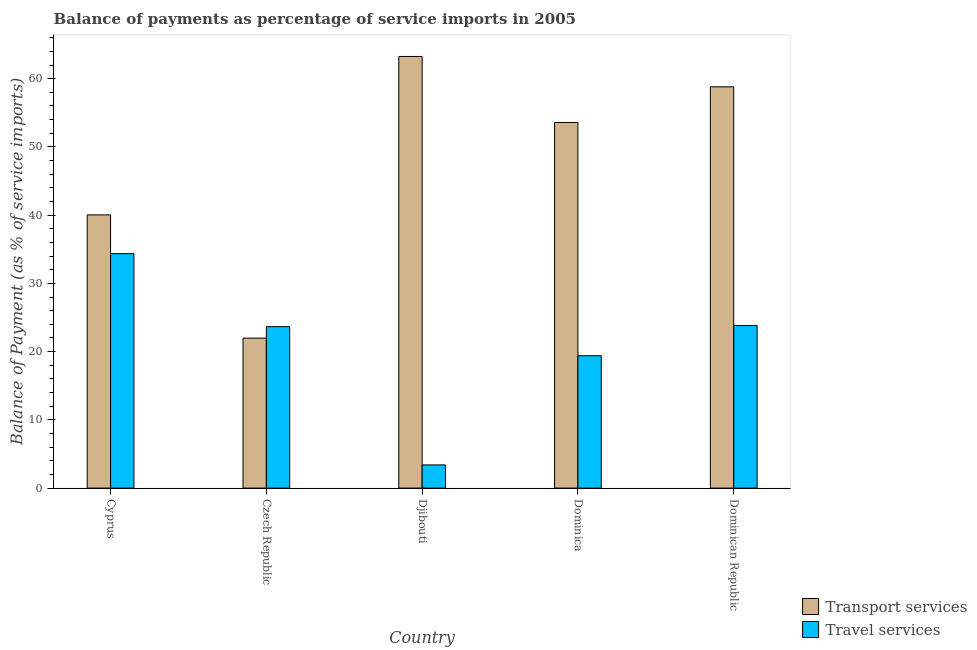How many different coloured bars are there?
Offer a terse response. 2. What is the label of the 3rd group of bars from the left?
Offer a very short reply. Djibouti. What is the balance of payments of transport services in Dominican Republic?
Provide a short and direct response. 58.81. Across all countries, what is the maximum balance of payments of transport services?
Your answer should be very brief. 63.26. Across all countries, what is the minimum balance of payments of transport services?
Provide a succinct answer. 21.98. In which country was the balance of payments of transport services maximum?
Provide a short and direct response. Djibouti. In which country was the balance of payments of travel services minimum?
Provide a short and direct response. Djibouti. What is the total balance of payments of travel services in the graph?
Ensure brevity in your answer.  104.64. What is the difference between the balance of payments of transport services in Czech Republic and that in Djibouti?
Your answer should be compact. -41.28. What is the difference between the balance of payments of transport services in Cyprus and the balance of payments of travel services in Dominica?
Your answer should be compact. 20.64. What is the average balance of payments of transport services per country?
Your answer should be very brief. 47.53. What is the difference between the balance of payments of travel services and balance of payments of transport services in Dominica?
Offer a very short reply. -34.19. In how many countries, is the balance of payments of transport services greater than 34 %?
Offer a very short reply. 4. What is the ratio of the balance of payments of travel services in Dominica to that in Dominican Republic?
Give a very brief answer. 0.81. Is the difference between the balance of payments of transport services in Cyprus and Dominican Republic greater than the difference between the balance of payments of travel services in Cyprus and Dominican Republic?
Provide a short and direct response. No. What is the difference between the highest and the second highest balance of payments of travel services?
Ensure brevity in your answer.  10.53. What is the difference between the highest and the lowest balance of payments of travel services?
Provide a succinct answer. 30.96. What does the 1st bar from the left in Czech Republic represents?
Offer a terse response. Transport services. What does the 1st bar from the right in Czech Republic represents?
Provide a short and direct response. Travel services. How many bars are there?
Make the answer very short. 10. Are all the bars in the graph horizontal?
Provide a succinct answer. No. What is the difference between two consecutive major ticks on the Y-axis?
Your response must be concise. 10. Are the values on the major ticks of Y-axis written in scientific E-notation?
Offer a very short reply. No. Does the graph contain any zero values?
Provide a short and direct response. No. Where does the legend appear in the graph?
Your answer should be compact. Bottom right. How are the legend labels stacked?
Offer a terse response. Vertical. What is the title of the graph?
Your answer should be compact. Balance of payments as percentage of service imports in 2005. What is the label or title of the X-axis?
Your response must be concise. Country. What is the label or title of the Y-axis?
Offer a terse response. Balance of Payment (as % of service imports). What is the Balance of Payment (as % of service imports) of Transport services in Cyprus?
Keep it short and to the point. 40.04. What is the Balance of Payment (as % of service imports) in Travel services in Cyprus?
Offer a very short reply. 34.36. What is the Balance of Payment (as % of service imports) of Transport services in Czech Republic?
Provide a short and direct response. 21.98. What is the Balance of Payment (as % of service imports) of Travel services in Czech Republic?
Your answer should be very brief. 23.66. What is the Balance of Payment (as % of service imports) of Transport services in Djibouti?
Offer a very short reply. 63.26. What is the Balance of Payment (as % of service imports) of Travel services in Djibouti?
Make the answer very short. 3.4. What is the Balance of Payment (as % of service imports) of Transport services in Dominica?
Your answer should be compact. 53.58. What is the Balance of Payment (as % of service imports) in Travel services in Dominica?
Keep it short and to the point. 19.4. What is the Balance of Payment (as % of service imports) in Transport services in Dominican Republic?
Your answer should be compact. 58.81. What is the Balance of Payment (as % of service imports) of Travel services in Dominican Republic?
Ensure brevity in your answer.  23.83. Across all countries, what is the maximum Balance of Payment (as % of service imports) of Transport services?
Your answer should be compact. 63.26. Across all countries, what is the maximum Balance of Payment (as % of service imports) in Travel services?
Your answer should be compact. 34.36. Across all countries, what is the minimum Balance of Payment (as % of service imports) in Transport services?
Your answer should be very brief. 21.98. Across all countries, what is the minimum Balance of Payment (as % of service imports) of Travel services?
Your answer should be compact. 3.4. What is the total Balance of Payment (as % of service imports) of Transport services in the graph?
Offer a terse response. 237.67. What is the total Balance of Payment (as % of service imports) of Travel services in the graph?
Offer a very short reply. 104.64. What is the difference between the Balance of Payment (as % of service imports) in Transport services in Cyprus and that in Czech Republic?
Ensure brevity in your answer.  18.06. What is the difference between the Balance of Payment (as % of service imports) of Travel services in Cyprus and that in Czech Republic?
Make the answer very short. 10.7. What is the difference between the Balance of Payment (as % of service imports) in Transport services in Cyprus and that in Djibouti?
Ensure brevity in your answer.  -23.22. What is the difference between the Balance of Payment (as % of service imports) of Travel services in Cyprus and that in Djibouti?
Your answer should be compact. 30.96. What is the difference between the Balance of Payment (as % of service imports) of Transport services in Cyprus and that in Dominica?
Your response must be concise. -13.54. What is the difference between the Balance of Payment (as % of service imports) in Travel services in Cyprus and that in Dominica?
Provide a short and direct response. 14.96. What is the difference between the Balance of Payment (as % of service imports) in Transport services in Cyprus and that in Dominican Republic?
Offer a terse response. -18.77. What is the difference between the Balance of Payment (as % of service imports) in Travel services in Cyprus and that in Dominican Republic?
Make the answer very short. 10.53. What is the difference between the Balance of Payment (as % of service imports) of Transport services in Czech Republic and that in Djibouti?
Your response must be concise. -41.28. What is the difference between the Balance of Payment (as % of service imports) of Travel services in Czech Republic and that in Djibouti?
Offer a terse response. 20.26. What is the difference between the Balance of Payment (as % of service imports) in Transport services in Czech Republic and that in Dominica?
Ensure brevity in your answer.  -31.61. What is the difference between the Balance of Payment (as % of service imports) in Travel services in Czech Republic and that in Dominica?
Offer a very short reply. 4.26. What is the difference between the Balance of Payment (as % of service imports) in Transport services in Czech Republic and that in Dominican Republic?
Offer a very short reply. -36.83. What is the difference between the Balance of Payment (as % of service imports) of Travel services in Czech Republic and that in Dominican Republic?
Make the answer very short. -0.17. What is the difference between the Balance of Payment (as % of service imports) of Transport services in Djibouti and that in Dominica?
Make the answer very short. 9.67. What is the difference between the Balance of Payment (as % of service imports) of Travel services in Djibouti and that in Dominica?
Offer a terse response. -16. What is the difference between the Balance of Payment (as % of service imports) of Transport services in Djibouti and that in Dominican Republic?
Give a very brief answer. 4.45. What is the difference between the Balance of Payment (as % of service imports) of Travel services in Djibouti and that in Dominican Republic?
Make the answer very short. -20.43. What is the difference between the Balance of Payment (as % of service imports) in Transport services in Dominica and that in Dominican Republic?
Give a very brief answer. -5.22. What is the difference between the Balance of Payment (as % of service imports) in Travel services in Dominica and that in Dominican Republic?
Your answer should be very brief. -4.43. What is the difference between the Balance of Payment (as % of service imports) in Transport services in Cyprus and the Balance of Payment (as % of service imports) in Travel services in Czech Republic?
Provide a succinct answer. 16.38. What is the difference between the Balance of Payment (as % of service imports) of Transport services in Cyprus and the Balance of Payment (as % of service imports) of Travel services in Djibouti?
Your response must be concise. 36.64. What is the difference between the Balance of Payment (as % of service imports) in Transport services in Cyprus and the Balance of Payment (as % of service imports) in Travel services in Dominica?
Provide a succinct answer. 20.64. What is the difference between the Balance of Payment (as % of service imports) in Transport services in Cyprus and the Balance of Payment (as % of service imports) in Travel services in Dominican Republic?
Your answer should be compact. 16.22. What is the difference between the Balance of Payment (as % of service imports) in Transport services in Czech Republic and the Balance of Payment (as % of service imports) in Travel services in Djibouti?
Your answer should be very brief. 18.58. What is the difference between the Balance of Payment (as % of service imports) in Transport services in Czech Republic and the Balance of Payment (as % of service imports) in Travel services in Dominica?
Your response must be concise. 2.58. What is the difference between the Balance of Payment (as % of service imports) of Transport services in Czech Republic and the Balance of Payment (as % of service imports) of Travel services in Dominican Republic?
Your response must be concise. -1.85. What is the difference between the Balance of Payment (as % of service imports) of Transport services in Djibouti and the Balance of Payment (as % of service imports) of Travel services in Dominica?
Your answer should be compact. 43.86. What is the difference between the Balance of Payment (as % of service imports) of Transport services in Djibouti and the Balance of Payment (as % of service imports) of Travel services in Dominican Republic?
Make the answer very short. 39.43. What is the difference between the Balance of Payment (as % of service imports) in Transport services in Dominica and the Balance of Payment (as % of service imports) in Travel services in Dominican Republic?
Offer a terse response. 29.76. What is the average Balance of Payment (as % of service imports) in Transport services per country?
Offer a terse response. 47.53. What is the average Balance of Payment (as % of service imports) in Travel services per country?
Ensure brevity in your answer.  20.93. What is the difference between the Balance of Payment (as % of service imports) in Transport services and Balance of Payment (as % of service imports) in Travel services in Cyprus?
Give a very brief answer. 5.68. What is the difference between the Balance of Payment (as % of service imports) in Transport services and Balance of Payment (as % of service imports) in Travel services in Czech Republic?
Give a very brief answer. -1.68. What is the difference between the Balance of Payment (as % of service imports) in Transport services and Balance of Payment (as % of service imports) in Travel services in Djibouti?
Your answer should be very brief. 59.86. What is the difference between the Balance of Payment (as % of service imports) of Transport services and Balance of Payment (as % of service imports) of Travel services in Dominica?
Give a very brief answer. 34.19. What is the difference between the Balance of Payment (as % of service imports) of Transport services and Balance of Payment (as % of service imports) of Travel services in Dominican Republic?
Your answer should be compact. 34.98. What is the ratio of the Balance of Payment (as % of service imports) in Transport services in Cyprus to that in Czech Republic?
Provide a succinct answer. 1.82. What is the ratio of the Balance of Payment (as % of service imports) of Travel services in Cyprus to that in Czech Republic?
Ensure brevity in your answer.  1.45. What is the ratio of the Balance of Payment (as % of service imports) of Transport services in Cyprus to that in Djibouti?
Provide a succinct answer. 0.63. What is the ratio of the Balance of Payment (as % of service imports) in Travel services in Cyprus to that in Djibouti?
Ensure brevity in your answer.  10.11. What is the ratio of the Balance of Payment (as % of service imports) in Transport services in Cyprus to that in Dominica?
Your response must be concise. 0.75. What is the ratio of the Balance of Payment (as % of service imports) of Travel services in Cyprus to that in Dominica?
Your answer should be compact. 1.77. What is the ratio of the Balance of Payment (as % of service imports) of Transport services in Cyprus to that in Dominican Republic?
Your response must be concise. 0.68. What is the ratio of the Balance of Payment (as % of service imports) of Travel services in Cyprus to that in Dominican Republic?
Give a very brief answer. 1.44. What is the ratio of the Balance of Payment (as % of service imports) in Transport services in Czech Republic to that in Djibouti?
Give a very brief answer. 0.35. What is the ratio of the Balance of Payment (as % of service imports) of Travel services in Czech Republic to that in Djibouti?
Your answer should be compact. 6.96. What is the ratio of the Balance of Payment (as % of service imports) in Transport services in Czech Republic to that in Dominica?
Keep it short and to the point. 0.41. What is the ratio of the Balance of Payment (as % of service imports) of Travel services in Czech Republic to that in Dominica?
Ensure brevity in your answer.  1.22. What is the ratio of the Balance of Payment (as % of service imports) of Transport services in Czech Republic to that in Dominican Republic?
Ensure brevity in your answer.  0.37. What is the ratio of the Balance of Payment (as % of service imports) of Transport services in Djibouti to that in Dominica?
Ensure brevity in your answer.  1.18. What is the ratio of the Balance of Payment (as % of service imports) of Travel services in Djibouti to that in Dominica?
Offer a terse response. 0.18. What is the ratio of the Balance of Payment (as % of service imports) in Transport services in Djibouti to that in Dominican Republic?
Offer a very short reply. 1.08. What is the ratio of the Balance of Payment (as % of service imports) in Travel services in Djibouti to that in Dominican Republic?
Make the answer very short. 0.14. What is the ratio of the Balance of Payment (as % of service imports) in Transport services in Dominica to that in Dominican Republic?
Ensure brevity in your answer.  0.91. What is the ratio of the Balance of Payment (as % of service imports) of Travel services in Dominica to that in Dominican Republic?
Provide a short and direct response. 0.81. What is the difference between the highest and the second highest Balance of Payment (as % of service imports) in Transport services?
Give a very brief answer. 4.45. What is the difference between the highest and the second highest Balance of Payment (as % of service imports) in Travel services?
Your answer should be very brief. 10.53. What is the difference between the highest and the lowest Balance of Payment (as % of service imports) in Transport services?
Give a very brief answer. 41.28. What is the difference between the highest and the lowest Balance of Payment (as % of service imports) in Travel services?
Provide a succinct answer. 30.96. 